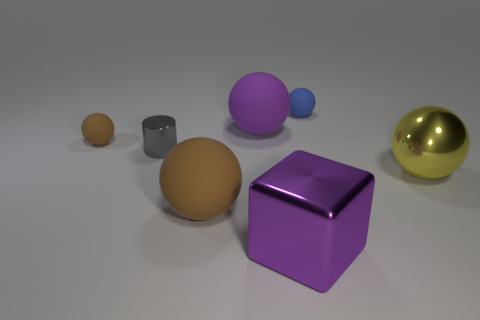Is the size of the cylinder the same as the yellow ball?
Keep it short and to the point. No. The rubber object that is both on the right side of the tiny brown sphere and in front of the large purple rubber thing is what color?
Give a very brief answer. Brown. What number of large purple objects have the same material as the big brown thing?
Your answer should be very brief. 1. How many cyan metal objects are there?
Provide a succinct answer. 0. Does the shiny block have the same size as the brown rubber thing in front of the yellow metallic sphere?
Ensure brevity in your answer.  Yes. The big ball to the right of the purple object in front of the purple sphere is made of what material?
Make the answer very short. Metal. There is a object left of the small shiny cylinder that is left of the purple object that is to the right of the big purple sphere; what size is it?
Your answer should be very brief. Small. Is the shape of the large brown object the same as the large purple thing behind the small gray cylinder?
Offer a terse response. Yes. What material is the small brown object?
Offer a terse response. Rubber. What number of metallic objects are large yellow spheres or large cylinders?
Offer a terse response. 1. 